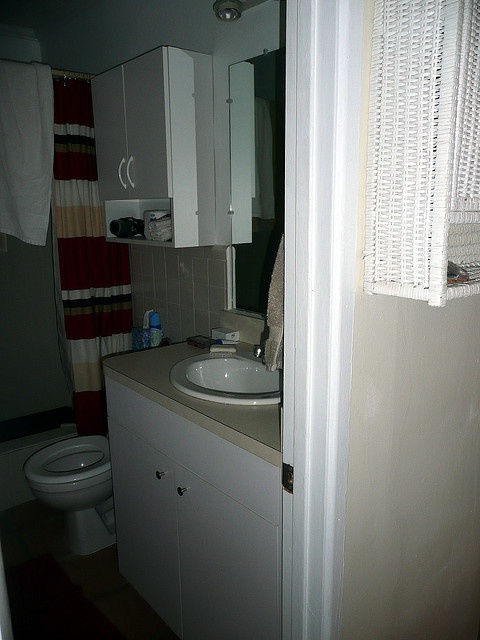Describe the objects in this image and their specific colors. I can see toilet in black and gray tones, sink in black, gray, and darkgray tones, and hair drier in black and gray tones in this image. 